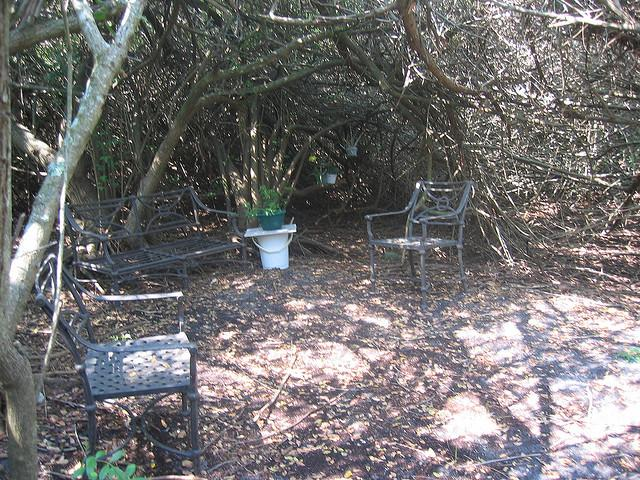What is near the flower pot?

Choices:
A) boat
B) chair
C) anteater
D) dog chair 